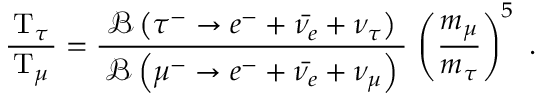<formula> <loc_0><loc_0><loc_500><loc_500>{ \frac { \, T _ { \tau } \, } { T _ { \mu } } } = { \frac { \, { \mathcal { B } } \left ( \tau ^ { - } \rightarrow e ^ { - } + { \bar { \nu _ { e } } } + \nu _ { \tau } \right ) \, } { { \mathcal { B } } \left ( \mu ^ { - } \rightarrow e ^ { - } + { \bar { \nu _ { e } } } + \nu _ { \mu } \right ) } } \, \left ( { \frac { m _ { \mu } } { m _ { \tau } } } \right ) ^ { 5 } .</formula> 